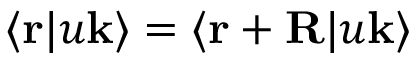Convert formula to latex. <formula><loc_0><loc_0><loc_500><loc_500>\langle r | u k \rangle = \langle r + R | u k \rangle</formula> 